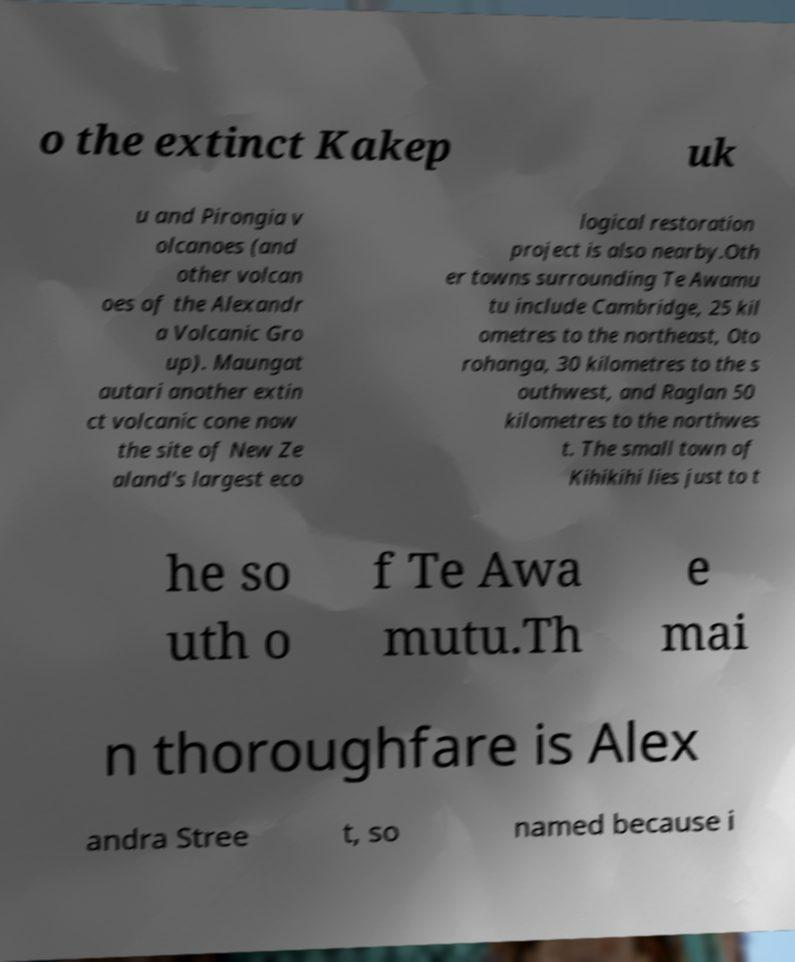For documentation purposes, I need the text within this image transcribed. Could you provide that? o the extinct Kakep uk u and Pirongia v olcanoes (and other volcan oes of the Alexandr a Volcanic Gro up). Maungat autari another extin ct volcanic cone now the site of New Ze aland's largest eco logical restoration project is also nearby.Oth er towns surrounding Te Awamu tu include Cambridge, 25 kil ometres to the northeast, Oto rohanga, 30 kilometres to the s outhwest, and Raglan 50 kilometres to the northwes t. The small town of Kihikihi lies just to t he so uth o f Te Awa mutu.Th e mai n thoroughfare is Alex andra Stree t, so named because i 